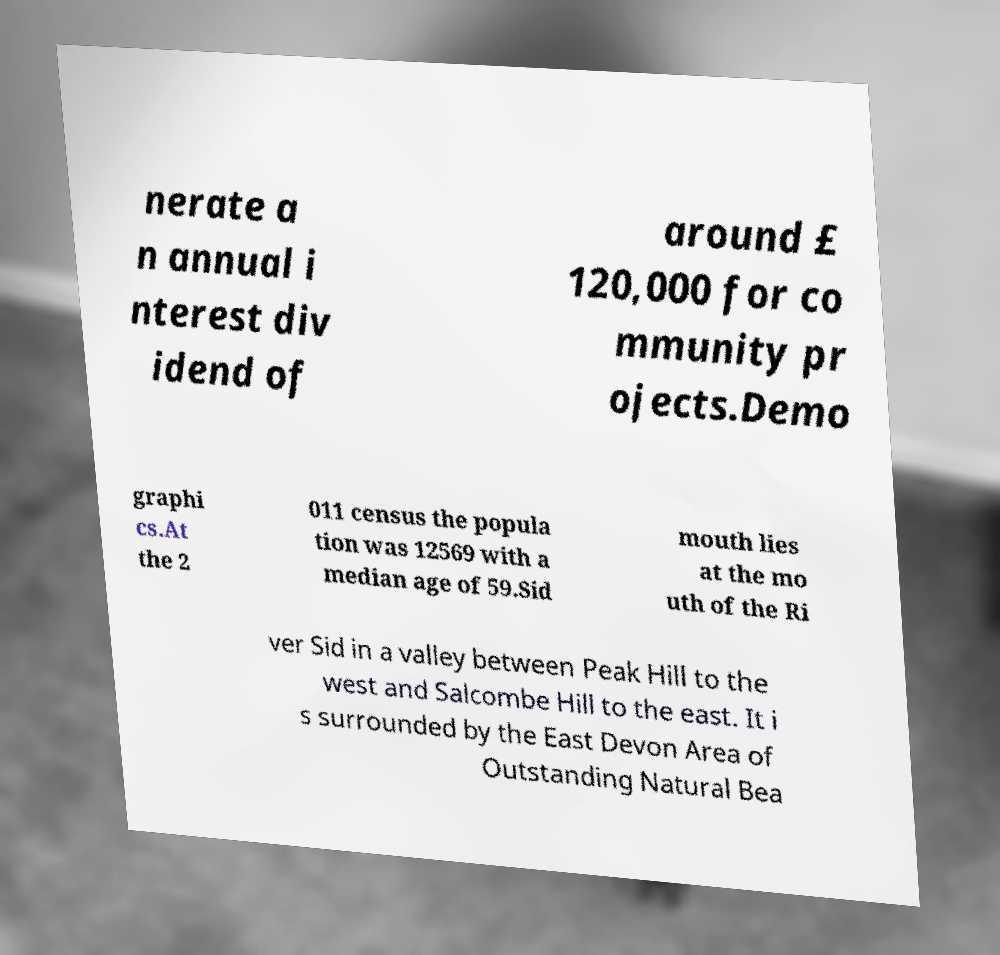For documentation purposes, I need the text within this image transcribed. Could you provide that? nerate a n annual i nterest div idend of around £ 120,000 for co mmunity pr ojects.Demo graphi cs.At the 2 011 census the popula tion was 12569 with a median age of 59.Sid mouth lies at the mo uth of the Ri ver Sid in a valley between Peak Hill to the west and Salcombe Hill to the east. It i s surrounded by the East Devon Area of Outstanding Natural Bea 